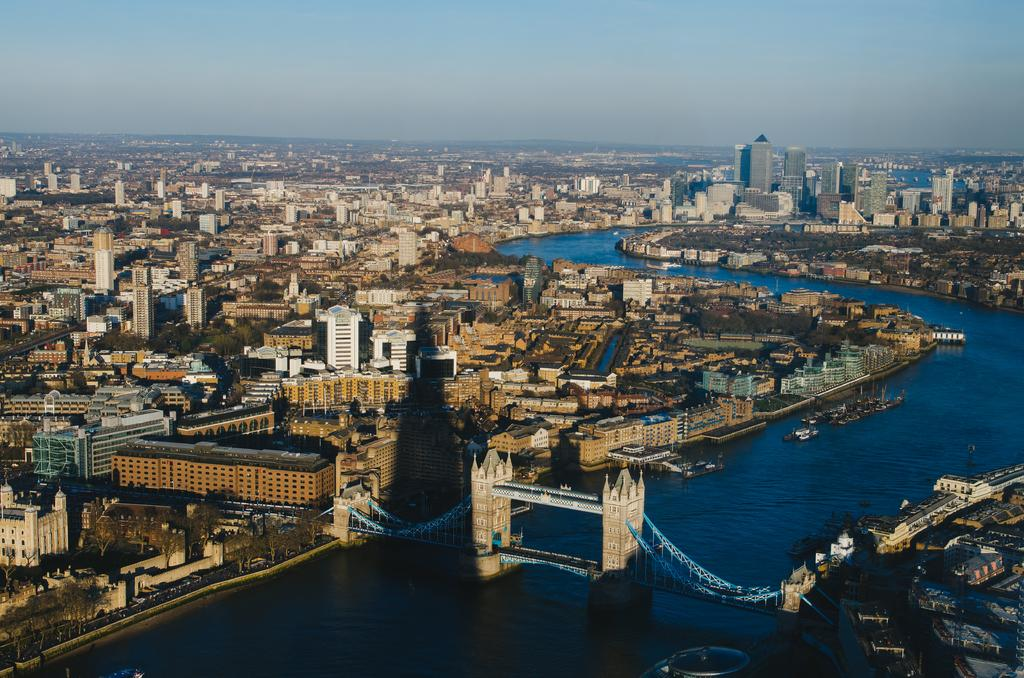What type of structure can be seen in the image? There is a bridge in the image. What natural element is visible in the image? There is water visible in the image. What type of man-made structures can be seen in the image? There are buildings in the image. What type of vegetation is present in the image? There are trees in the image. What other objects can be seen in the image? There are some objects in the image. What is visible in the background of the image? The sky is visible in the background of the image. What type of plastic material is used to construct the bridge in the image? There is no information about the bridge's construction material in the image, and no plastic material is mentioned. 